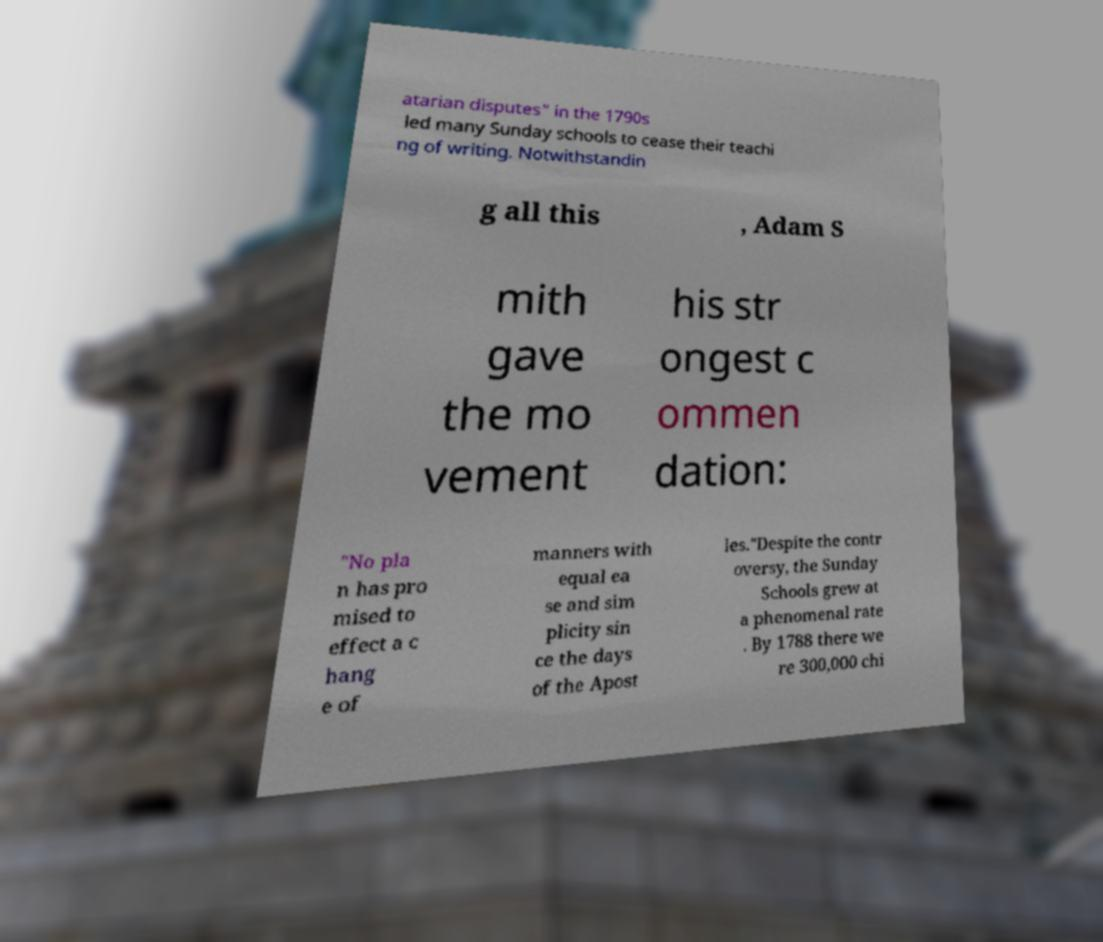Can you read and provide the text displayed in the image?This photo seems to have some interesting text. Can you extract and type it out for me? atarian disputes" in the 1790s led many Sunday schools to cease their teachi ng of writing. Notwithstandin g all this , Adam S mith gave the mo vement his str ongest c ommen dation: "No pla n has pro mised to effect a c hang e of manners with equal ea se and sim plicity sin ce the days of the Apost les."Despite the contr oversy, the Sunday Schools grew at a phenomenal rate . By 1788 there we re 300,000 chi 